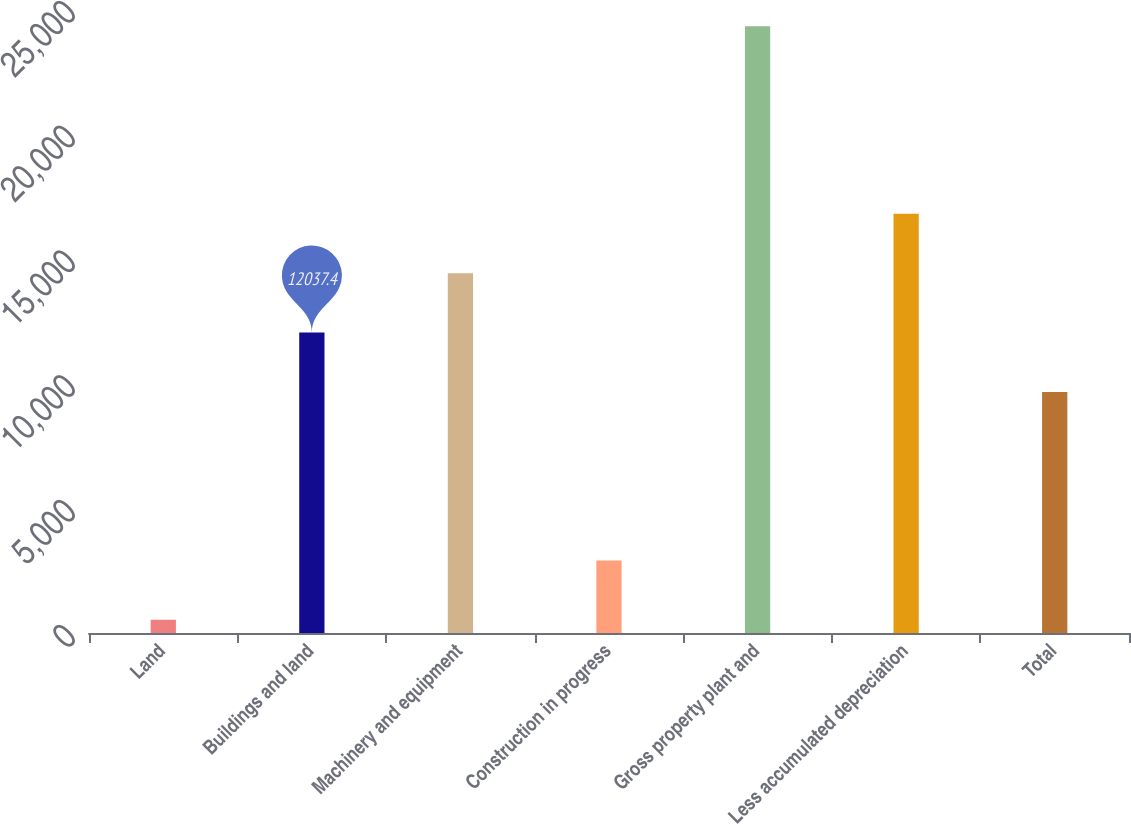Convert chart to OTSL. <chart><loc_0><loc_0><loc_500><loc_500><bar_chart><fcel>Land<fcel>Buildings and land<fcel>Machinery and equipment<fcel>Construction in progress<fcel>Gross property plant and<fcel>Less accumulated depreciation<fcel>Total<nl><fcel>531<fcel>12037.4<fcel>14414.8<fcel>2908.4<fcel>24305<fcel>16792.2<fcel>9660<nl></chart> 